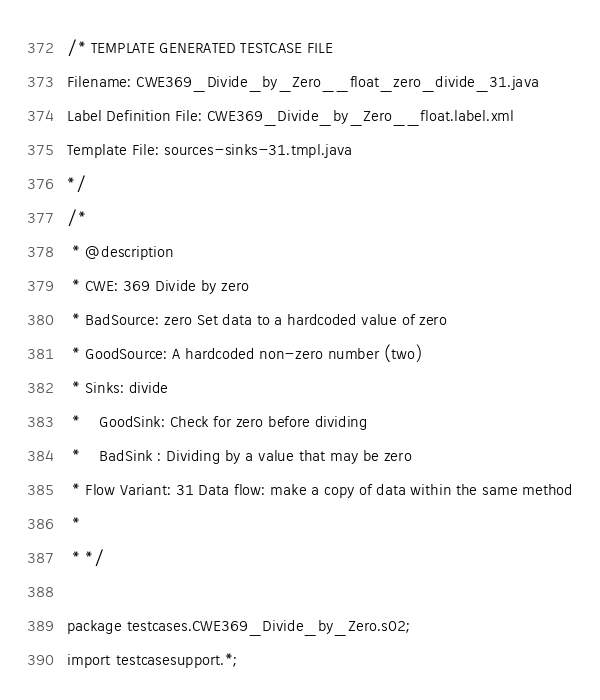<code> <loc_0><loc_0><loc_500><loc_500><_Java_>/* TEMPLATE GENERATED TESTCASE FILE
Filename: CWE369_Divide_by_Zero__float_zero_divide_31.java
Label Definition File: CWE369_Divide_by_Zero__float.label.xml
Template File: sources-sinks-31.tmpl.java
*/
/*
 * @description
 * CWE: 369 Divide by zero
 * BadSource: zero Set data to a hardcoded value of zero
 * GoodSource: A hardcoded non-zero number (two)
 * Sinks: divide
 *    GoodSink: Check for zero before dividing
 *    BadSink : Dividing by a value that may be zero
 * Flow Variant: 31 Data flow: make a copy of data within the same method
 *
 * */

package testcases.CWE369_Divide_by_Zero.s02;
import testcasesupport.*;
</code> 